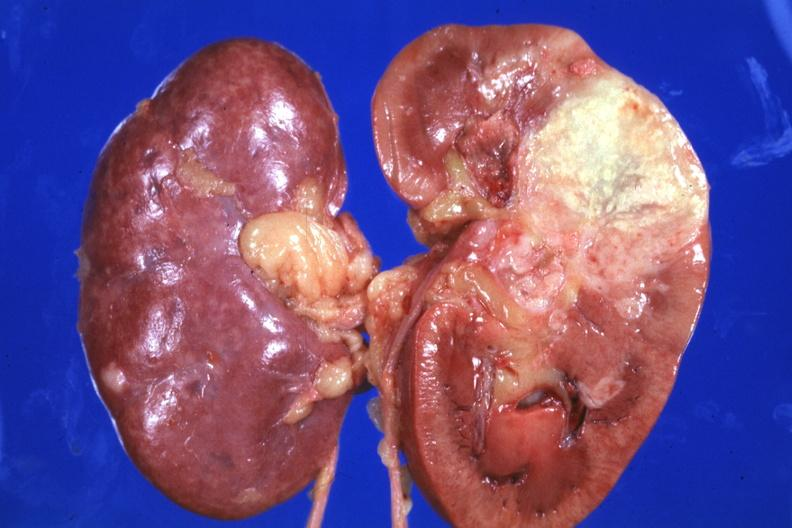what is present?
Answer the question using a single word or phrase. Metastatic carcinoma lung 